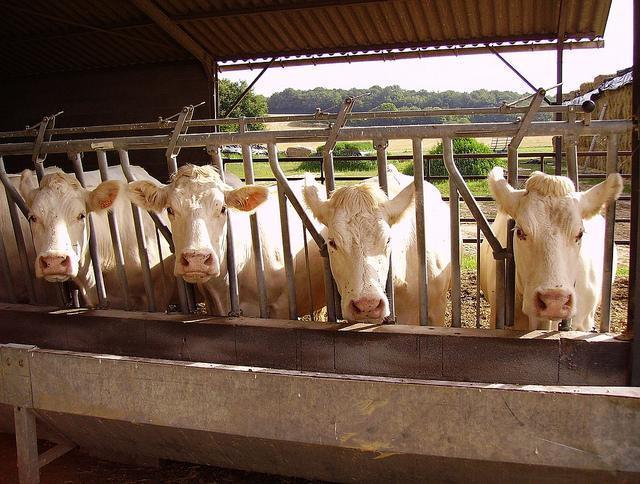How many noses do you see?
Give a very brief answer. 4. How many cows are in the picture?
Give a very brief answer. 5. How many sandwiches have white bread?
Give a very brief answer. 0. 